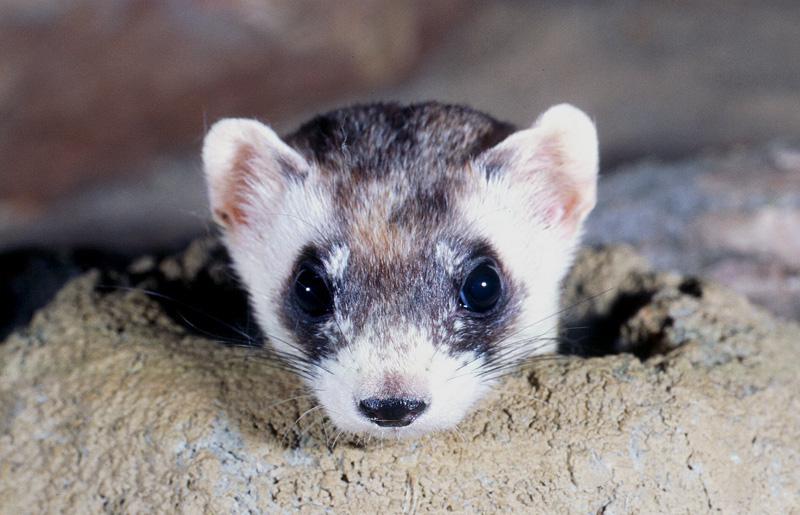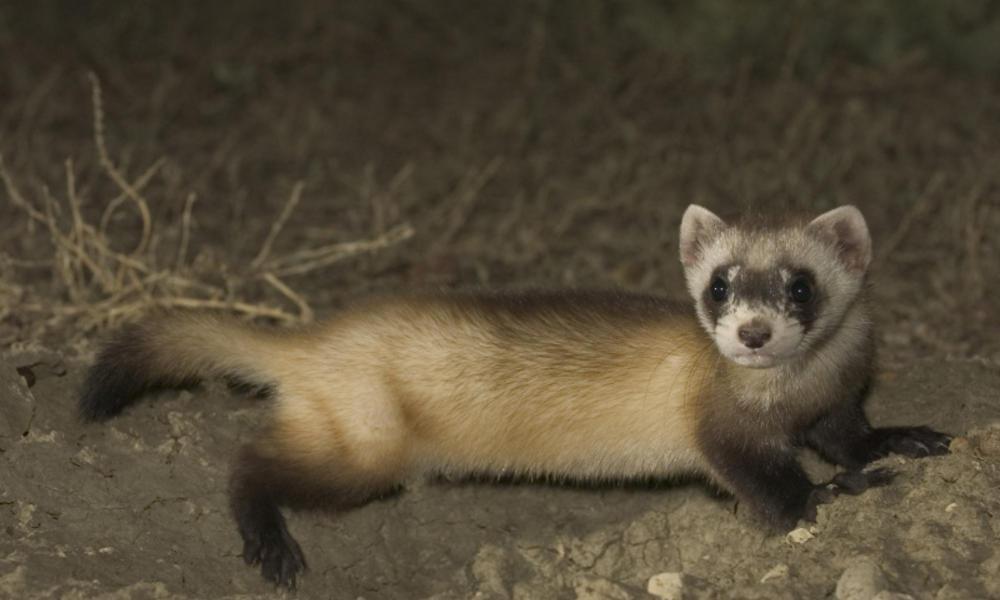The first image is the image on the left, the second image is the image on the right. Evaluate the accuracy of this statement regarding the images: "There is only one weasel coming out of a hole in one of the pictures.". Is it true? Answer yes or no. Yes. The first image is the image on the left, the second image is the image on the right. Analyze the images presented: Is the assertion "At least one photograph shows exactly one animal with light brown, rather than black, markings around its eyes." valid? Answer yes or no. No. 